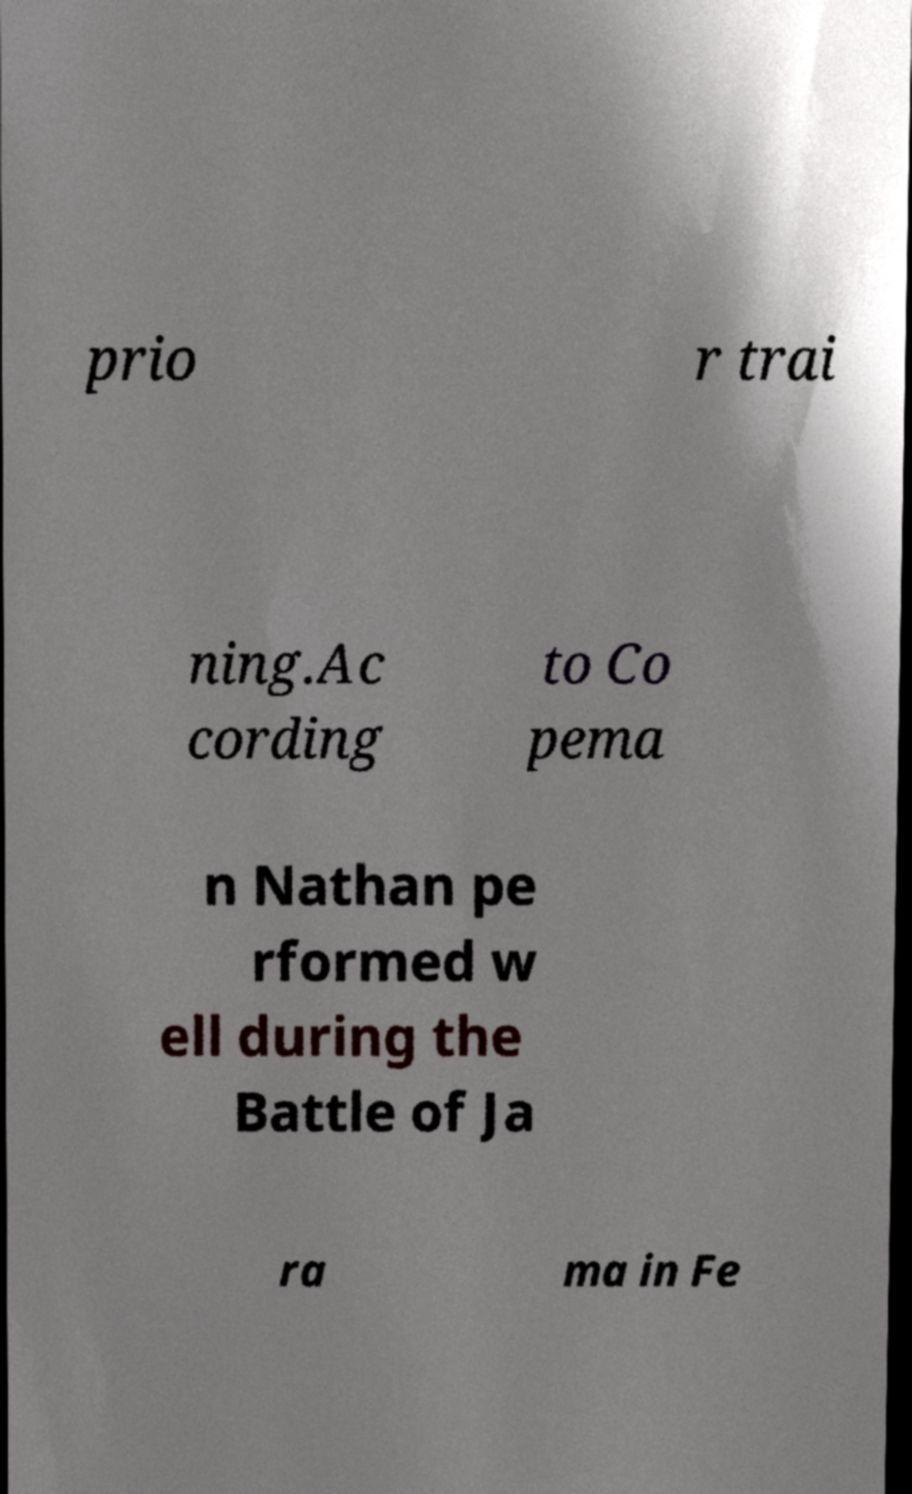What messages or text are displayed in this image? I need them in a readable, typed format. prio r trai ning.Ac cording to Co pema n Nathan pe rformed w ell during the Battle of Ja ra ma in Fe 